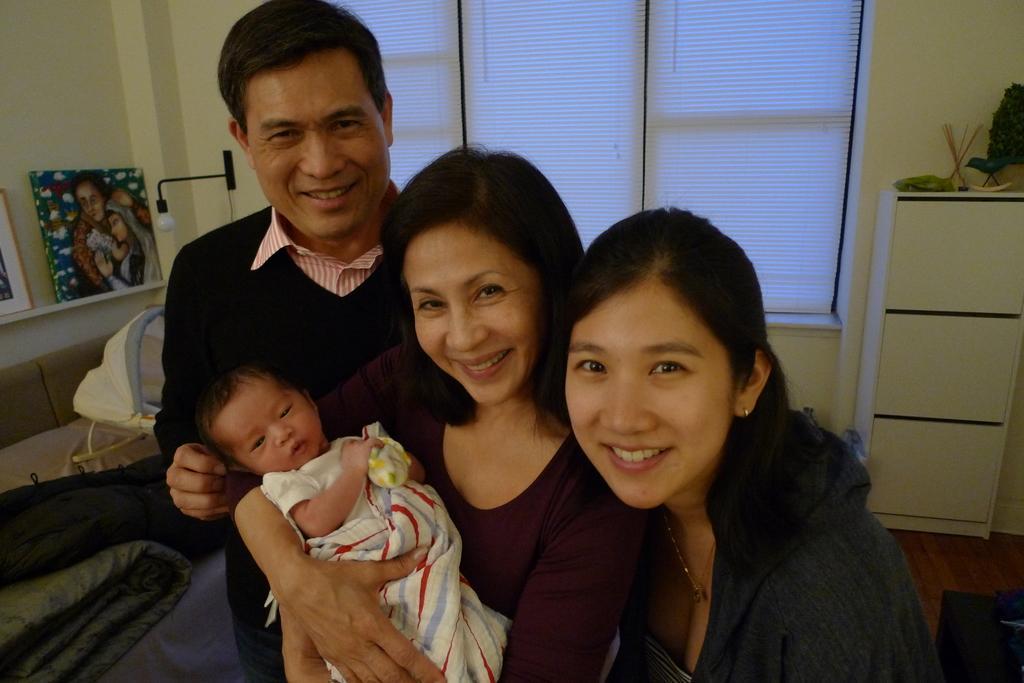Can you describe this image briefly? In this image I can see three people standing and one person is holding baby. Back I can see blankets,frames on the shelf. I can see a window,lamp,wall and cupboard. 